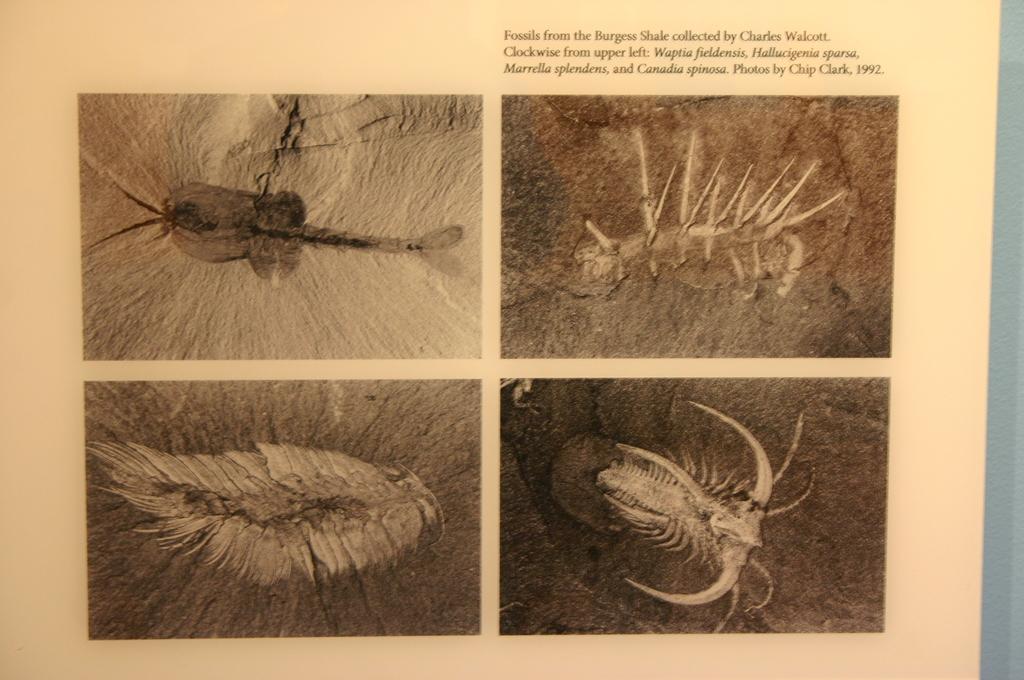In one or two sentences, can you explain what this image depicts? In this image we can see a paper, in that paper, there are some pictures of fossils, also we can see some text. 